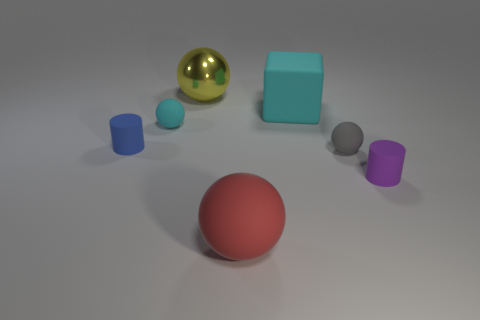What number of things have the same color as the big block?
Provide a short and direct response. 1. Is the shape of the tiny rubber thing in front of the tiny gray matte object the same as  the blue matte object?
Make the answer very short. Yes. Is the red matte object the same shape as the yellow object?
Provide a short and direct response. Yes. What is the material of the object that is the same color as the big rubber block?
Provide a short and direct response. Rubber. Is the size of the red ball the same as the blue matte cylinder?
Offer a terse response. No. What is the tiny thing that is in front of the tiny cyan rubber object and left of the big yellow thing made of?
Your answer should be compact. Rubber. Are there any gray balls that are behind the matte cylinder on the left side of the yellow sphere?
Give a very brief answer. No. There is a sphere that is both behind the large red thing and in front of the blue rubber cylinder; what is its size?
Your answer should be compact. Small. How many cyan things are tiny cylinders or big matte blocks?
Provide a short and direct response. 1. What is the shape of the blue thing that is the same size as the gray sphere?
Offer a very short reply. Cylinder. 